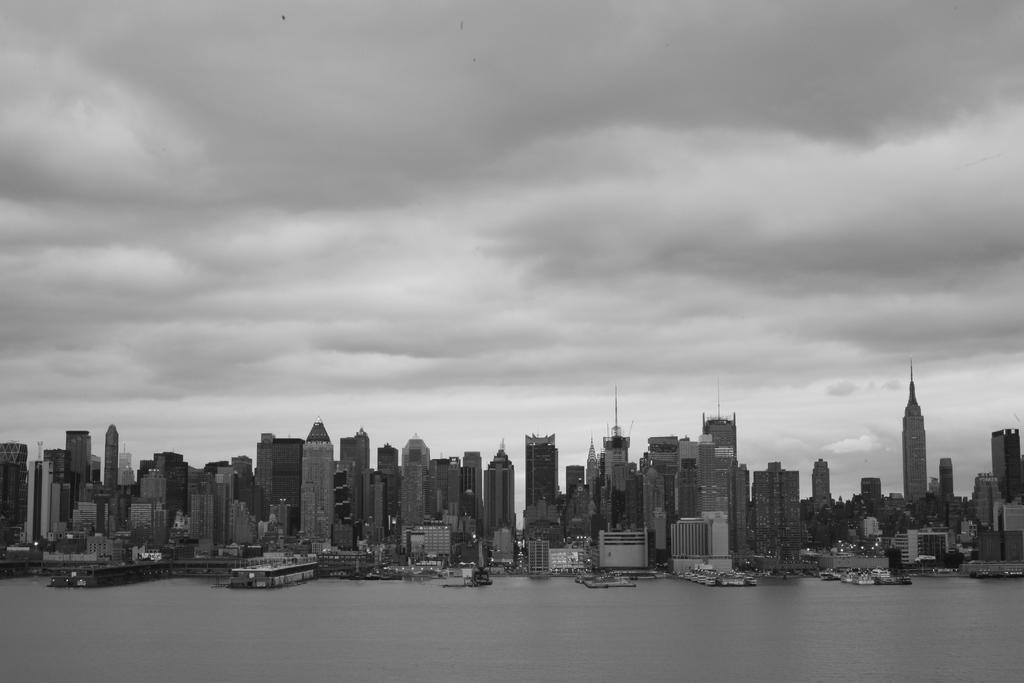What type of structures can be seen in the image? There are buildings in the image. What natural element is visible in the image? There is water visible in the image. What is the condition of the sky in the image? The sky is clear in the image. How is the image presented in terms of color? The image is in black and white color. What type of pin is being used by the committee in the image? There is no committee or pin present in the image; it features buildings, water, and a clear sky in black and white color. 